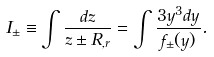<formula> <loc_0><loc_0><loc_500><loc_500>I _ { \pm } \equiv \int \frac { d z } { z \pm R _ { , r } } = \int \frac { 3 y ^ { 3 } d y } { f _ { \pm } ( y ) } .</formula> 